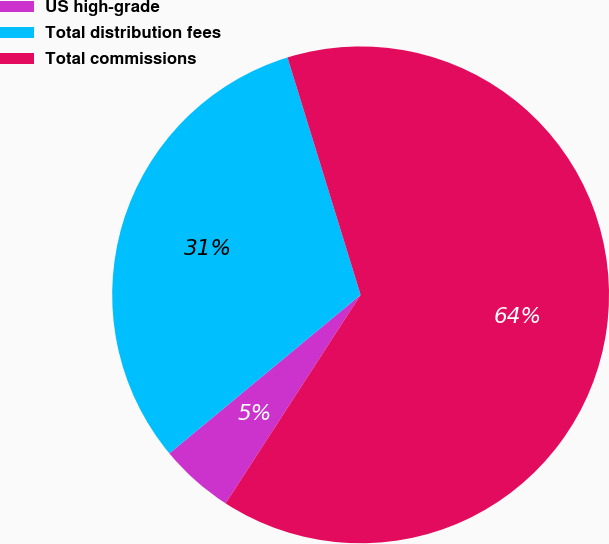<chart> <loc_0><loc_0><loc_500><loc_500><pie_chart><fcel>US high-grade<fcel>Total distribution fees<fcel>Total commissions<nl><fcel>4.84%<fcel>31.26%<fcel>63.9%<nl></chart> 